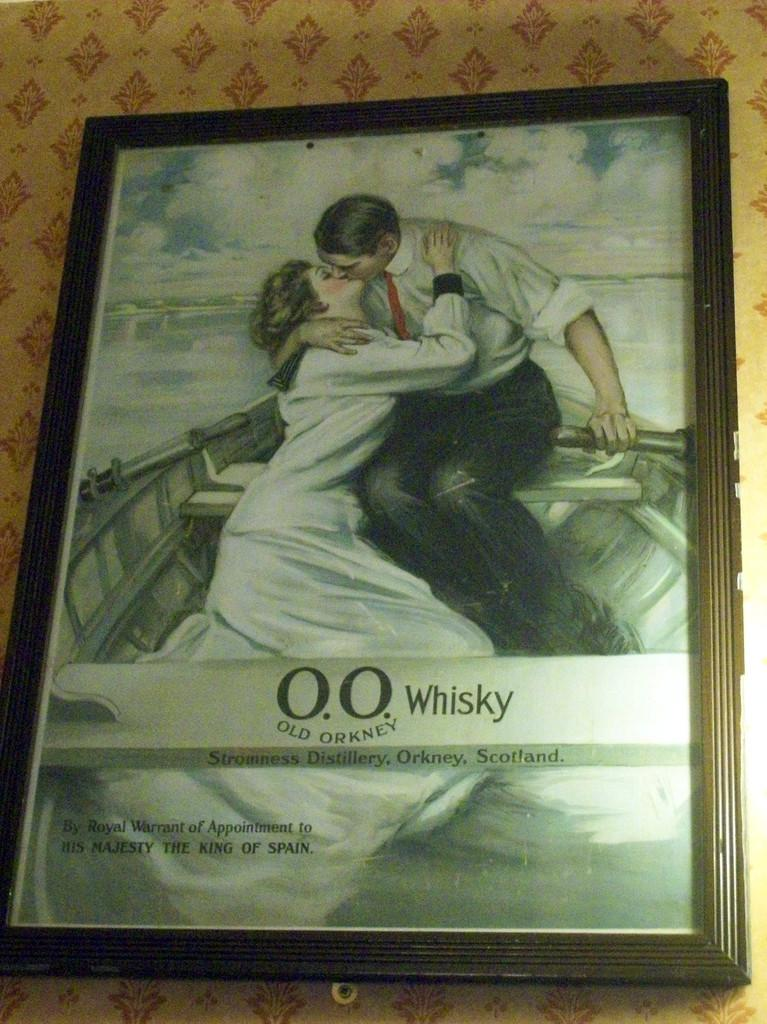What is the main subject of the image? There is a photo in the image. What can be seen in the photo? The photo contains two persons. What are the persons in the photo doing? The persons in the photo are sitting in a boat and kissing each other. Where is the photo located in the image? The photo is attached to a wall. What type of grain is visible in the image? There is no grain present in the image. How does the mailbox move in the image? There is no mailbox present in the image. 